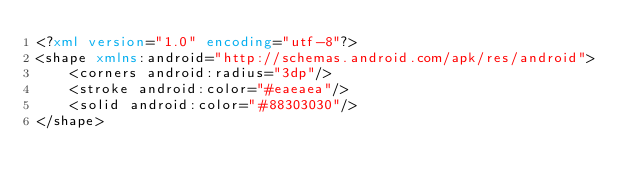<code> <loc_0><loc_0><loc_500><loc_500><_XML_><?xml version="1.0" encoding="utf-8"?>
<shape xmlns:android="http://schemas.android.com/apk/res/android">
    <corners android:radius="3dp"/>
    <stroke android:color="#eaeaea"/>
    <solid android:color="#88303030"/>
</shape></code> 